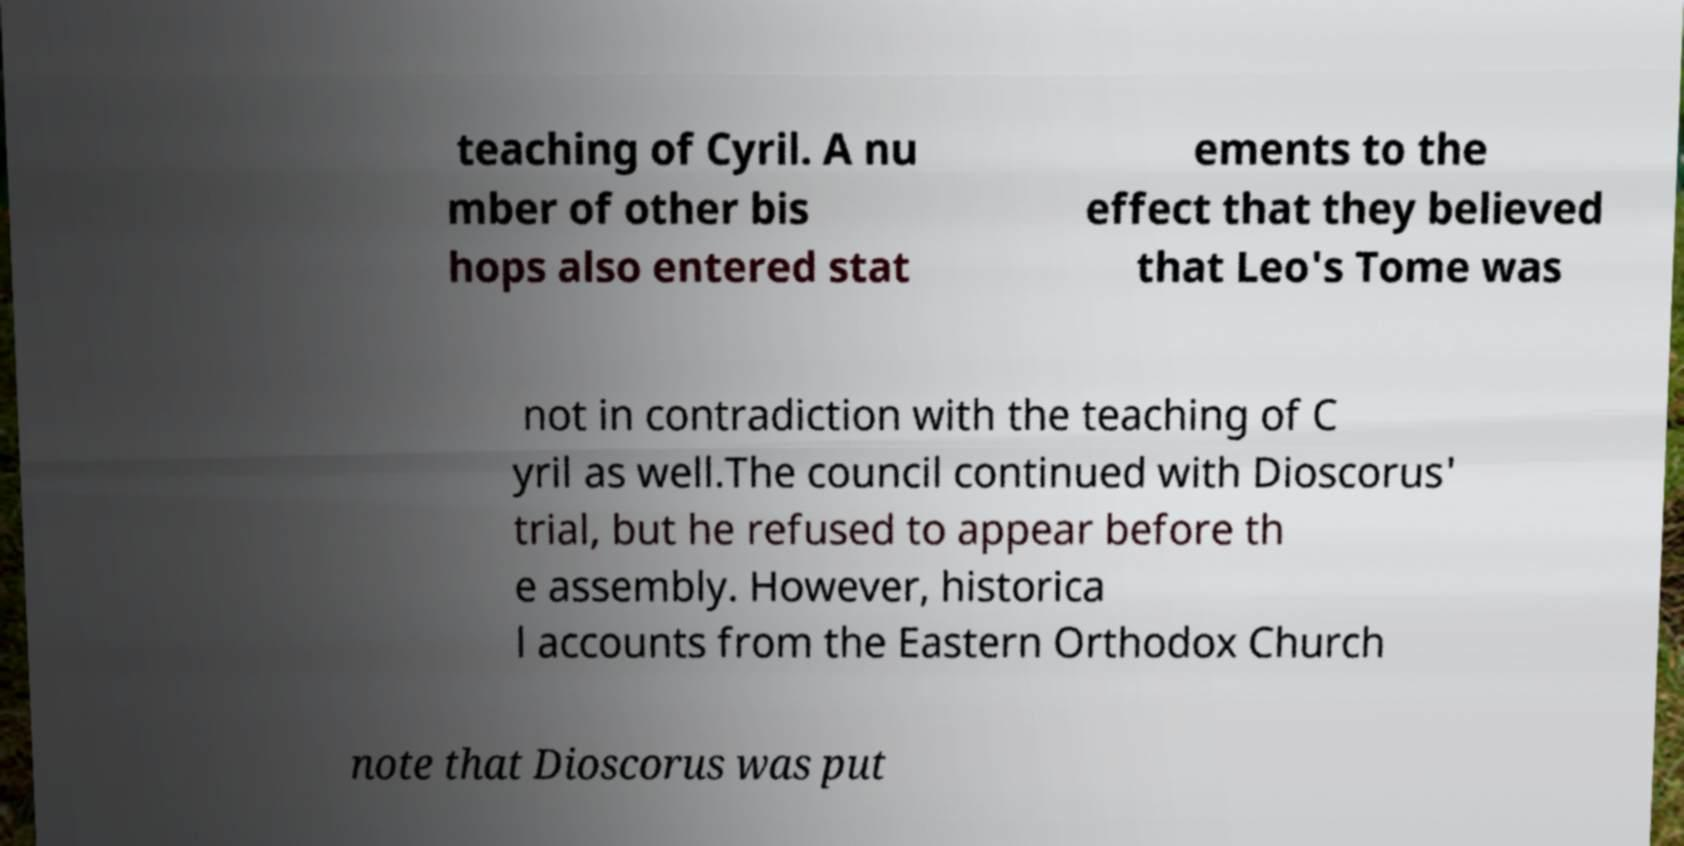There's text embedded in this image that I need extracted. Can you transcribe it verbatim? teaching of Cyril. A nu mber of other bis hops also entered stat ements to the effect that they believed that Leo's Tome was not in contradiction with the teaching of C yril as well.The council continued with Dioscorus' trial, but he refused to appear before th e assembly. However, historica l accounts from the Eastern Orthodox Church note that Dioscorus was put 